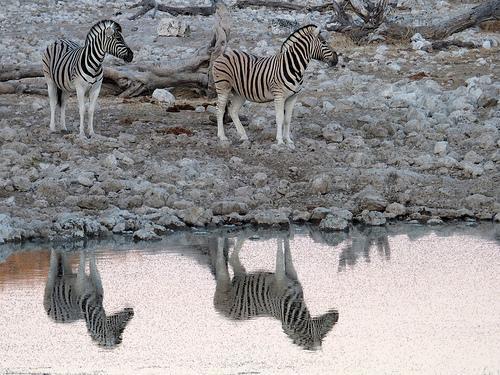How many zebras are shown?
Give a very brief answer. 2. 